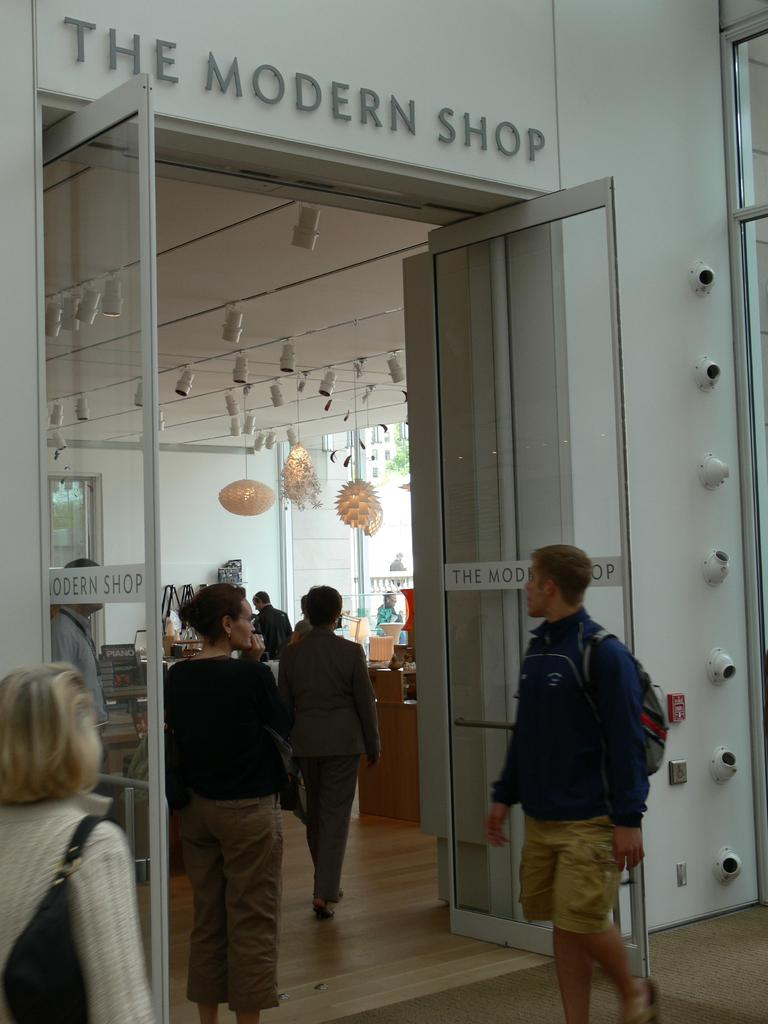What type of establishment is depicted in the image? There is a store in the image. Can you describe the people in the image? There are people in the image. What can be seen in the background of the image? There are decorations, doors, and walls in the background of the image. How many cows are visible in the image? There are no cows present in the image. What type of porter is assisting the customers in the image? There is no porter present in the image, and therefore no assistance can be observed. 